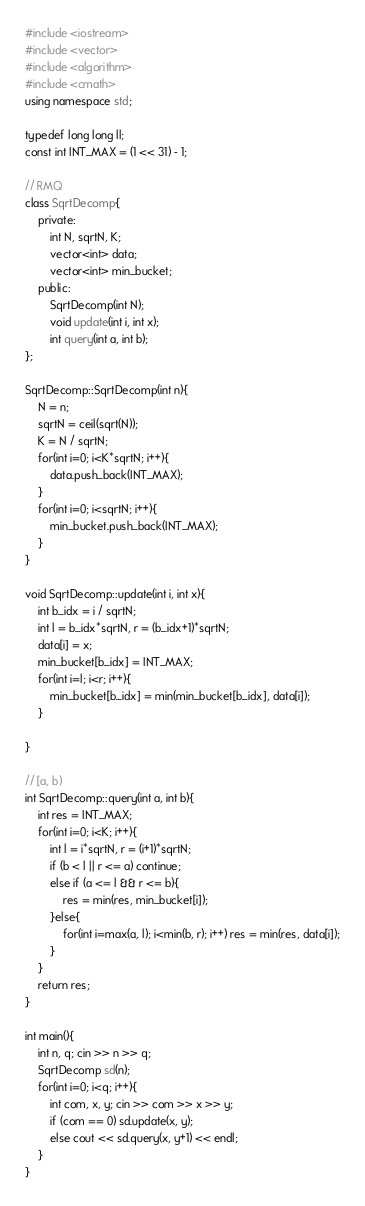<code> <loc_0><loc_0><loc_500><loc_500><_C++_>#include <iostream>
#include <vector>
#include <algorithm>
#include <cmath>
using namespace std;

typedef long long ll;
const int INT_MAX = (1 << 31) - 1;

// RMQ
class SqrtDecomp{
    private:
        int N, sqrtN, K;
        vector<int> data;
        vector<int> min_bucket;
    public:
        SqrtDecomp(int N);
        void update(int i, int x);
        int query(int a, int b);
};

SqrtDecomp::SqrtDecomp(int n){
    N = n;
    sqrtN = ceil(sqrt(N));
    K = N / sqrtN;
    for(int i=0; i<K*sqrtN; i++){
        data.push_back(INT_MAX);
    }
    for(int i=0; i<sqrtN; i++){
        min_bucket.push_back(INT_MAX);
    }
}

void SqrtDecomp::update(int i, int x){
    int b_idx = i / sqrtN;
    int l = b_idx*sqrtN, r = (b_idx+1)*sqrtN;
    data[i] = x;
    min_bucket[b_idx] = INT_MAX;
    for(int i=l; i<r; i++){
        min_bucket[b_idx] = min(min_bucket[b_idx], data[i]);
    }

}

// [a, b)
int SqrtDecomp::query(int a, int b){
    int res = INT_MAX;
    for(int i=0; i<K; i++){
        int l = i*sqrtN, r = (i+1)*sqrtN;
        if (b < l || r <= a) continue;
        else if (a <= l && r <= b){
            res = min(res, min_bucket[i]);
        }else{
            for(int i=max(a, l); i<min(b, r); i++) res = min(res, data[i]);
        }
    }
    return res;
}

int main(){
    int n, q; cin >> n >> q;
    SqrtDecomp sd(n);
    for(int i=0; i<q; i++){
        int com, x, y; cin >> com >> x >> y;
        if (com == 0) sd.update(x, y);
        else cout << sd.query(x, y+1) << endl;
    }
}

</code> 